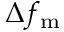Convert formula to latex. <formula><loc_0><loc_0><loc_500><loc_500>\Delta f _ { m }</formula> 